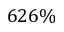<formula> <loc_0><loc_0><loc_500><loc_500>6 2 6 \%</formula> 